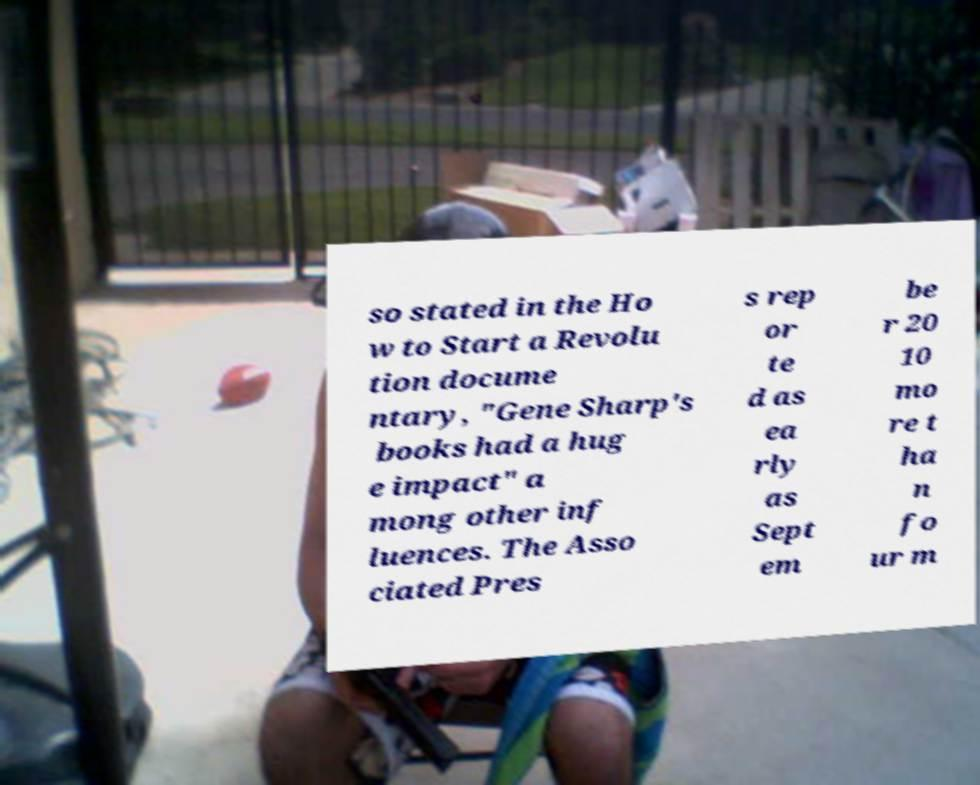For documentation purposes, I need the text within this image transcribed. Could you provide that? so stated in the Ho w to Start a Revolu tion docume ntary, "Gene Sharp's books had a hug e impact" a mong other inf luences. The Asso ciated Pres s rep or te d as ea rly as Sept em be r 20 10 mo re t ha n fo ur m 